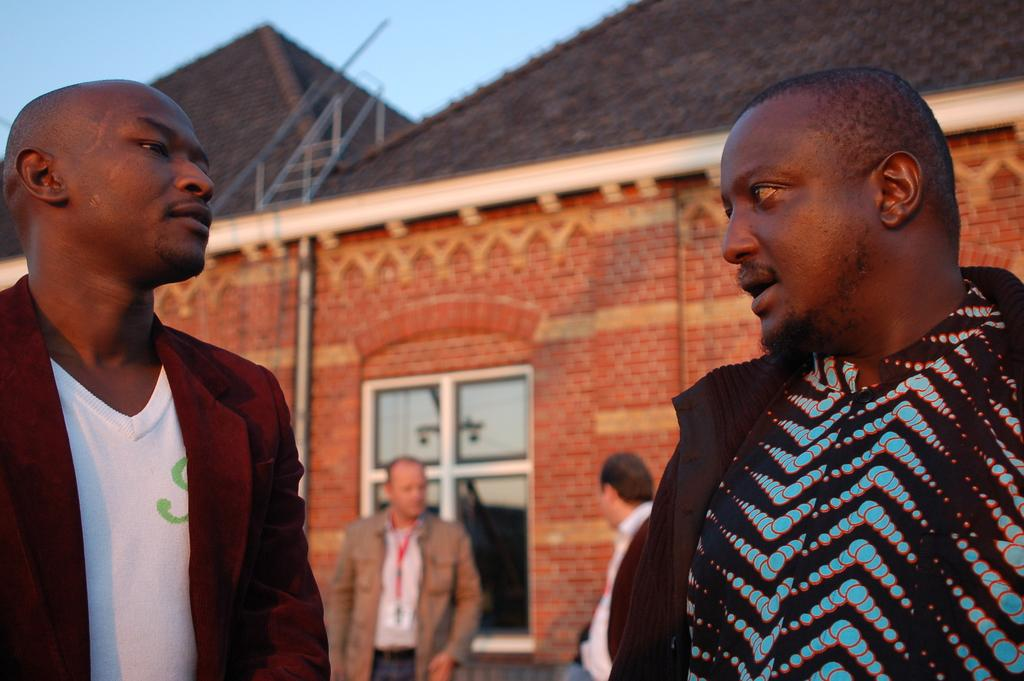How many boys are in the image? There are two African boys in the image. What are the boys doing in the image? The boys are standing and discussing something. What can be seen in the background of the image? There is a red color brick house in the background. What type of roof does the house have? The house has roof tiles. What type of science experiment can be seen being conducted by the boys in the image? There is no science experiment visible in the image; the boys are simply standing and discussing something. 